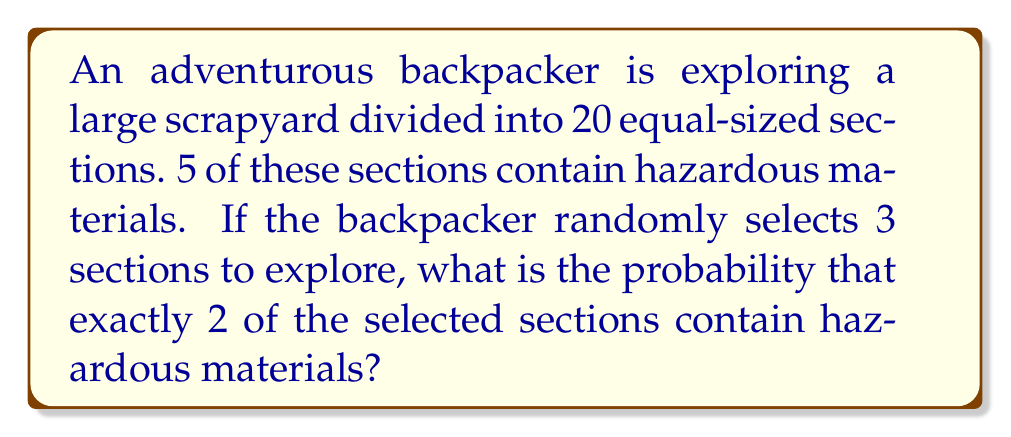Can you answer this question? To solve this problem, we'll use the hypergeometric distribution, which is appropriate for sampling without replacement from a finite population.

Let's define our variables:
- $N = 20$ (total number of sections)
- $K = 5$ (number of hazardous sections)
- $n = 3$ (number of sections selected)
- $k = 2$ (number of hazardous sections we want to select)

The probability mass function for the hypergeometric distribution is:

$$ P(X = k) = \frac{\binom{K}{k} \binom{N-K}{n-k}}{\binom{N}{n}} $$

Where $\binom{a}{b}$ represents the binomial coefficient, calculated as:

$$ \binom{a}{b} = \frac{a!}{b!(a-b)!} $$

Let's calculate each part:

1) $\binom{K}{k} = \binom{5}{2} = \frac{5!}{2!(5-2)!} = \frac{5 \cdot 4}{2 \cdot 1} = 10$

2) $\binom{N-K}{n-k} = \binom{15}{1} = \frac{15!}{1!(15-1)!} = 15$

3) $\binom{N}{n} = \binom{20}{3} = \frac{20!}{3!(20-3)!} = \frac{20 \cdot 19 \cdot 18}{3 \cdot 2 \cdot 1} = 1140$

Now, we can plug these values into our probability mass function:

$$ P(X = 2) = \frac{10 \cdot 15}{1140} = \frac{150}{1140} = \frac{25}{190} \approx 0.1316 $$
Answer: The probability of selecting exactly 2 hazardous sections out of 3 randomly chosen sections is $\frac{25}{190}$ or approximately 0.1316 (13.16%). 